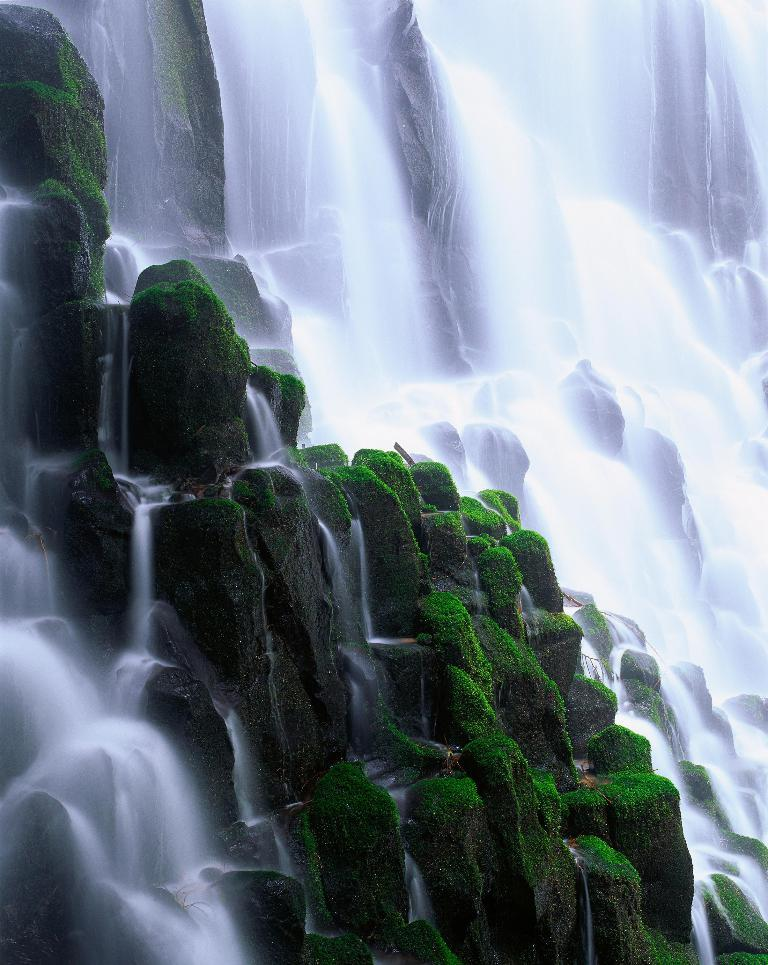What natural feature is located on the right side of the image? There is a waterfall on the right side of the image. What type of vegetation can be seen in the middle of the image? There appears to be moss in the middle of the image. What type of leather can be seen in the image? A: There is no leather present in the image. Are there any worms visible in the image? There are no worms visible in the image. 